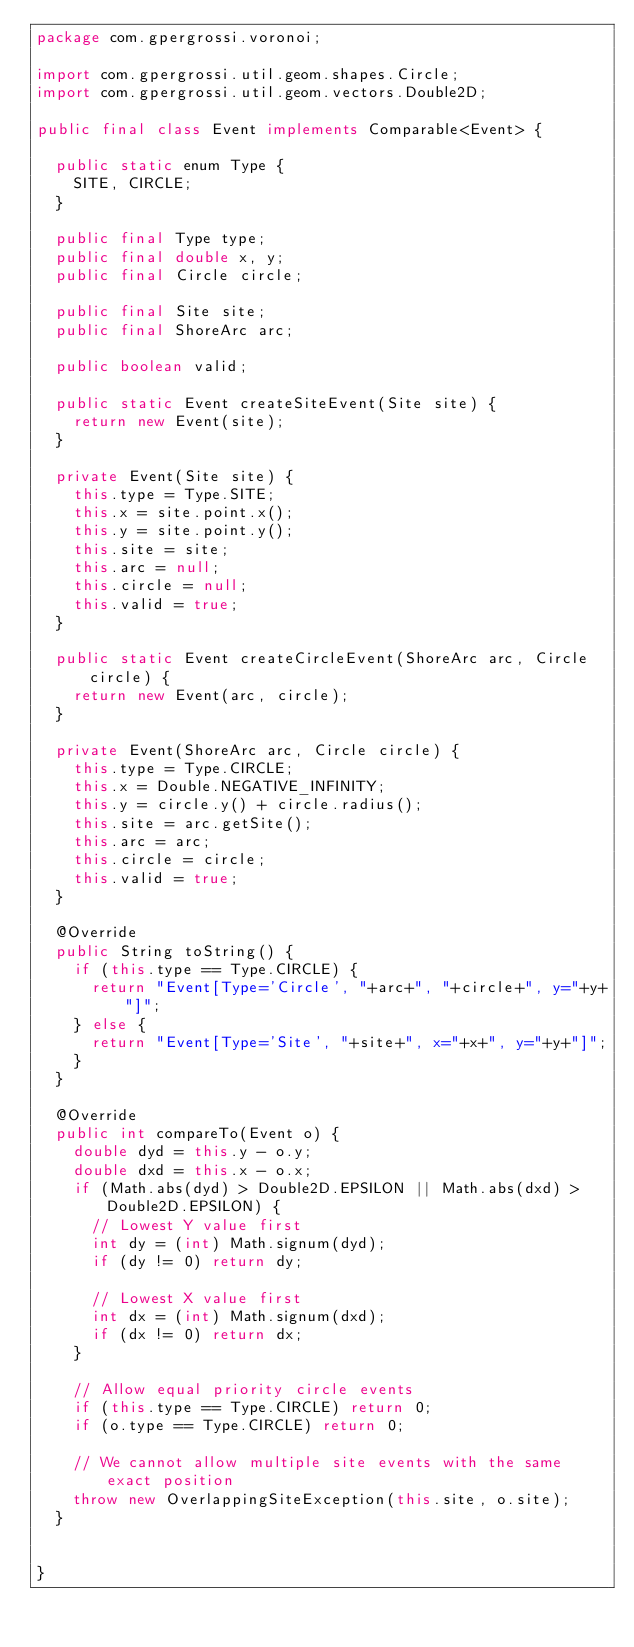Convert code to text. <code><loc_0><loc_0><loc_500><loc_500><_Java_>package com.gpergrossi.voronoi;

import com.gpergrossi.util.geom.shapes.Circle;
import com.gpergrossi.util.geom.vectors.Double2D;

public final class Event implements Comparable<Event> {

	public static enum Type {
		SITE, CIRCLE;
	}
	
	public final Type type;
	public final double x, y;
	public final Circle circle;
	
	public final Site site;
	public final ShoreArc arc;
	
	public boolean valid;
	
	public static Event createSiteEvent(Site site) {
		return new Event(site);
	}
	
	private Event(Site site) {
		this.type = Type.SITE;
		this.x = site.point.x();
		this.y = site.point.y();
		this.site = site;
		this.arc = null;
		this.circle = null;
		this.valid = true;
	}
	
	public static Event createCircleEvent(ShoreArc arc, Circle circle) {
		return new Event(arc, circle);
	}
	
	private Event(ShoreArc arc, Circle circle) {
		this.type = Type.CIRCLE;
		this.x = Double.NEGATIVE_INFINITY;
		this.y = circle.y() + circle.radius();
		this.site = arc.getSite();
		this.arc = arc;
		this.circle = circle;
		this.valid = true;
	}
	
	@Override
	public String toString() {
		if (this.type == Type.CIRCLE) {
			return "Event[Type='Circle', "+arc+", "+circle+", y="+y+"]";
		} else {
			return "Event[Type='Site', "+site+", x="+x+", y="+y+"]";
		}
	}

	@Override
	public int compareTo(Event o) {
		double dyd = this.y - o.y;
		double dxd = this.x - o.x;
		if (Math.abs(dyd) > Double2D.EPSILON || Math.abs(dxd) > Double2D.EPSILON) {
			// Lowest Y value first
			int dy = (int) Math.signum(dyd);
			if (dy != 0) return dy;
			
			// Lowest X value first
			int dx = (int) Math.signum(dxd);
			if (dx != 0) return dx;
		}
		
		// Allow equal priority circle events
		if (this.type == Type.CIRCLE) return 0;
		if (o.type == Type.CIRCLE) return 0;
		
		// We cannot allow multiple site events with the same exact position
		throw new OverlappingSiteException(this.site, o.site);
	}
	
	
}</code> 